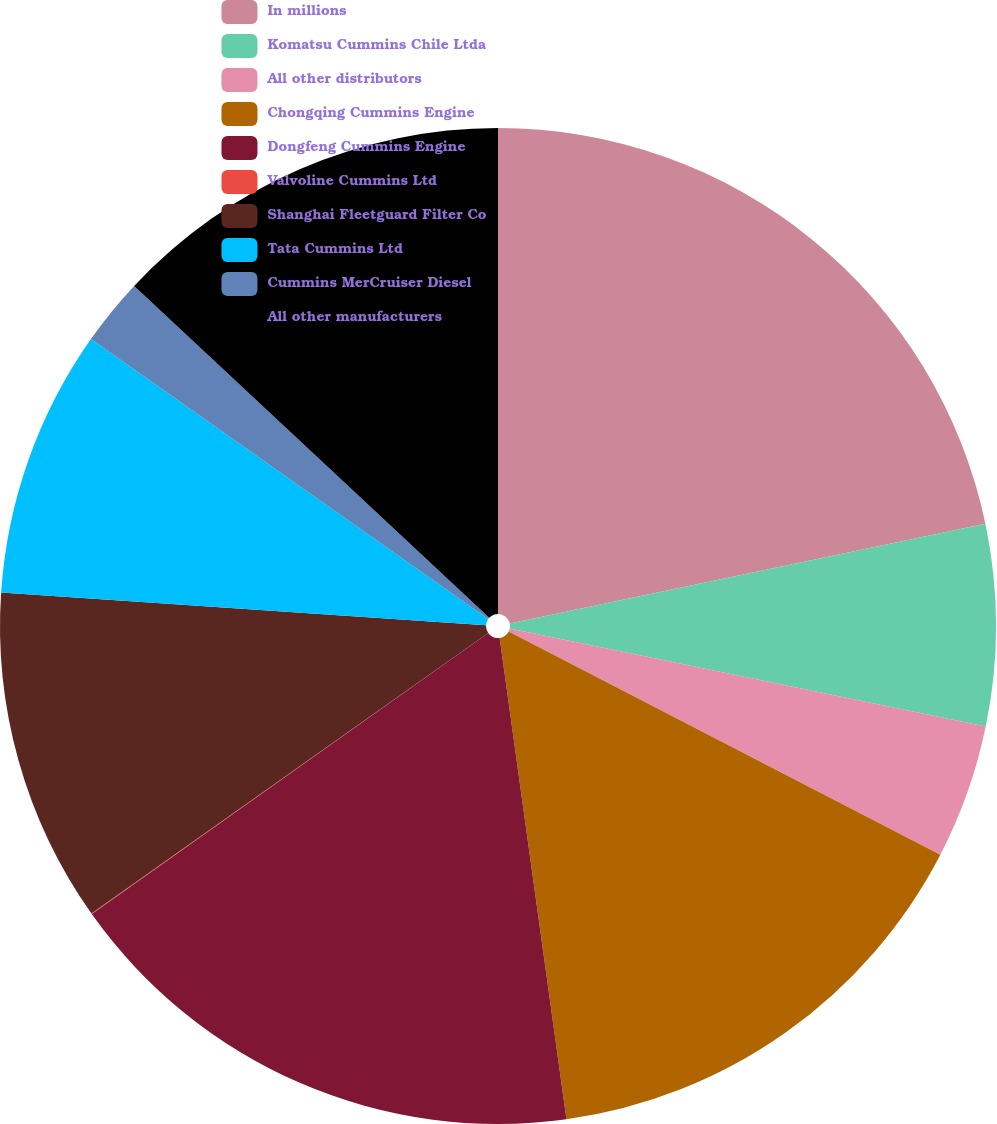Convert chart. <chart><loc_0><loc_0><loc_500><loc_500><pie_chart><fcel>In millions<fcel>Komatsu Cummins Chile Ltda<fcel>All other distributors<fcel>Chongqing Cummins Engine<fcel>Dongfeng Cummins Engine<fcel>Valvoline Cummins Ltd<fcel>Shanghai Fleetguard Filter Co<fcel>Tata Cummins Ltd<fcel>Cummins MerCruiser Diesel<fcel>All other manufacturers<nl><fcel>21.71%<fcel>6.53%<fcel>4.36%<fcel>15.21%<fcel>17.38%<fcel>0.02%<fcel>10.87%<fcel>8.7%<fcel>2.19%<fcel>13.04%<nl></chart> 